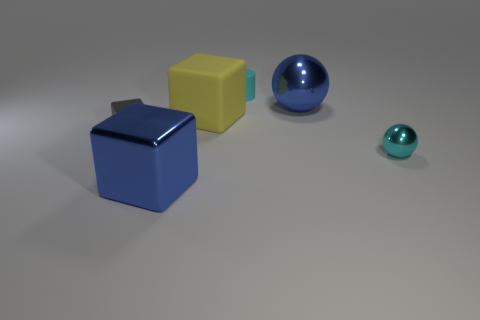There is a rubber thing that is the same size as the gray shiny cube; what is its shape?
Your response must be concise. Cylinder. Are there an equal number of metal spheres to the left of the gray thing and tiny blocks that are in front of the tiny cyan shiny thing?
Provide a succinct answer. Yes. Is there anything else that is the same shape as the cyan matte object?
Ensure brevity in your answer.  No. Are the large cube that is in front of the small cyan metallic sphere and the yellow thing made of the same material?
Ensure brevity in your answer.  No. There is a gray block that is the same size as the cyan ball; what is its material?
Your response must be concise. Metal. How many other things are there of the same material as the blue cube?
Ensure brevity in your answer.  3. There is a blue block; is its size the same as the cyan metallic thing in front of the cyan cylinder?
Give a very brief answer. No. Is the number of small metal spheres that are left of the cyan ball less than the number of large metal things behind the big matte object?
Offer a terse response. Yes. What size is the blue thing that is behind the large blue cube?
Your response must be concise. Large. Do the matte cylinder and the yellow cube have the same size?
Provide a succinct answer. No. 